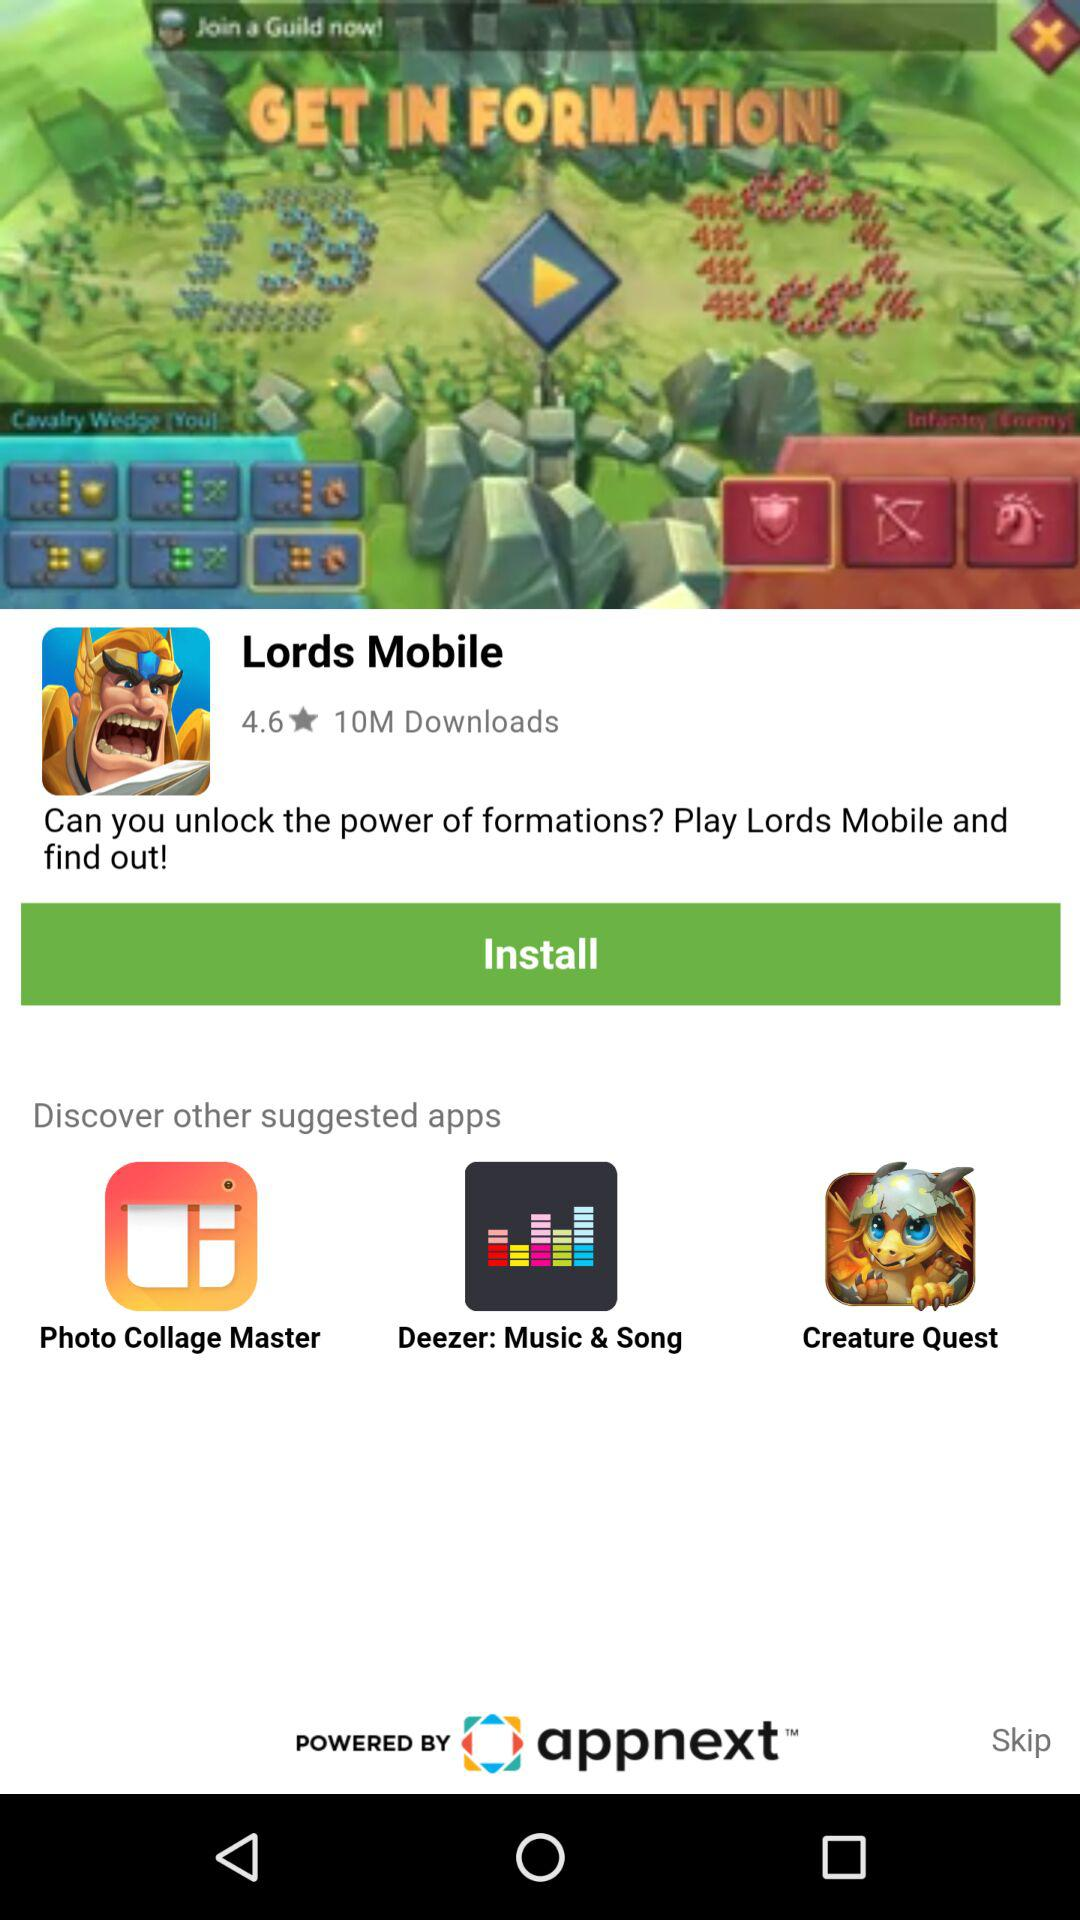What is the rating of "Lords Mobile"? The rating of "Lords Mobile" is 4.6. 